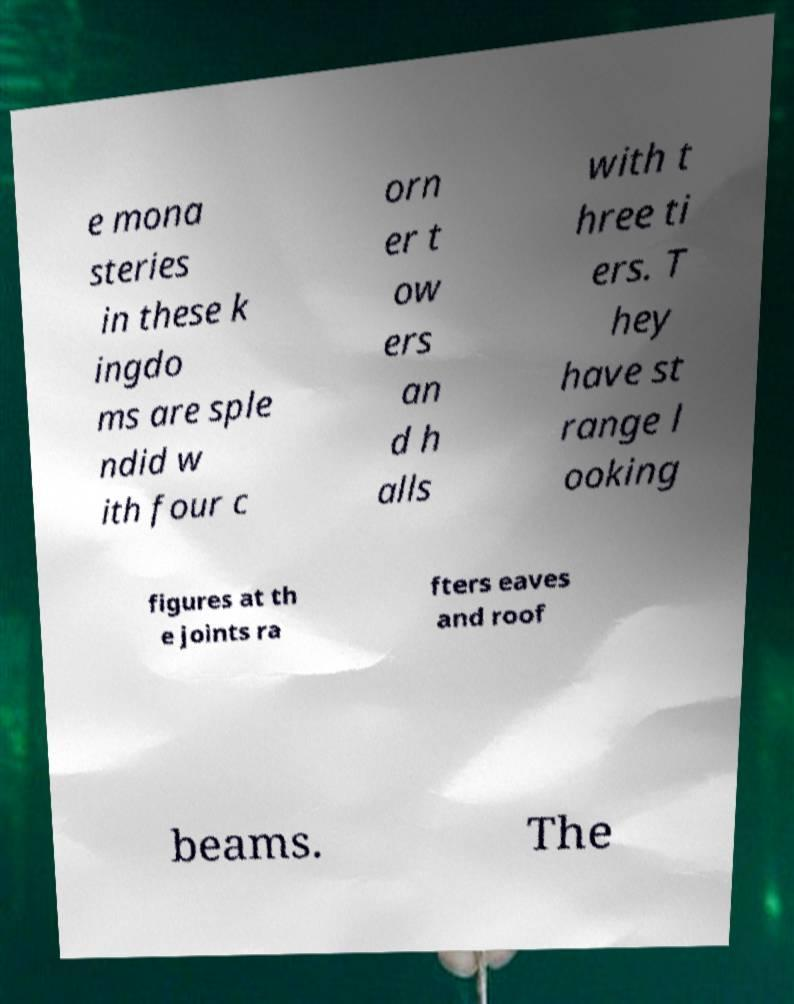Could you extract and type out the text from this image? e mona steries in these k ingdo ms are sple ndid w ith four c orn er t ow ers an d h alls with t hree ti ers. T hey have st range l ooking figures at th e joints ra fters eaves and roof beams. The 